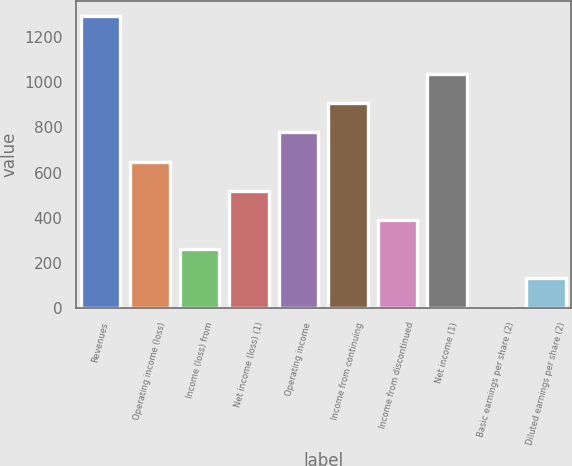Convert chart. <chart><loc_0><loc_0><loc_500><loc_500><bar_chart><fcel>Revenues<fcel>Operating income (loss)<fcel>Income (loss) from<fcel>Net income (loss) (1)<fcel>Operating income<fcel>Income from continuing<fcel>Income from discontinued<fcel>Net income (1)<fcel>Basic earnings per share (2)<fcel>Diluted earnings per share (2)<nl><fcel>1295<fcel>648.38<fcel>260.39<fcel>519.05<fcel>777.71<fcel>907.04<fcel>389.72<fcel>1036.37<fcel>1.73<fcel>131.06<nl></chart> 